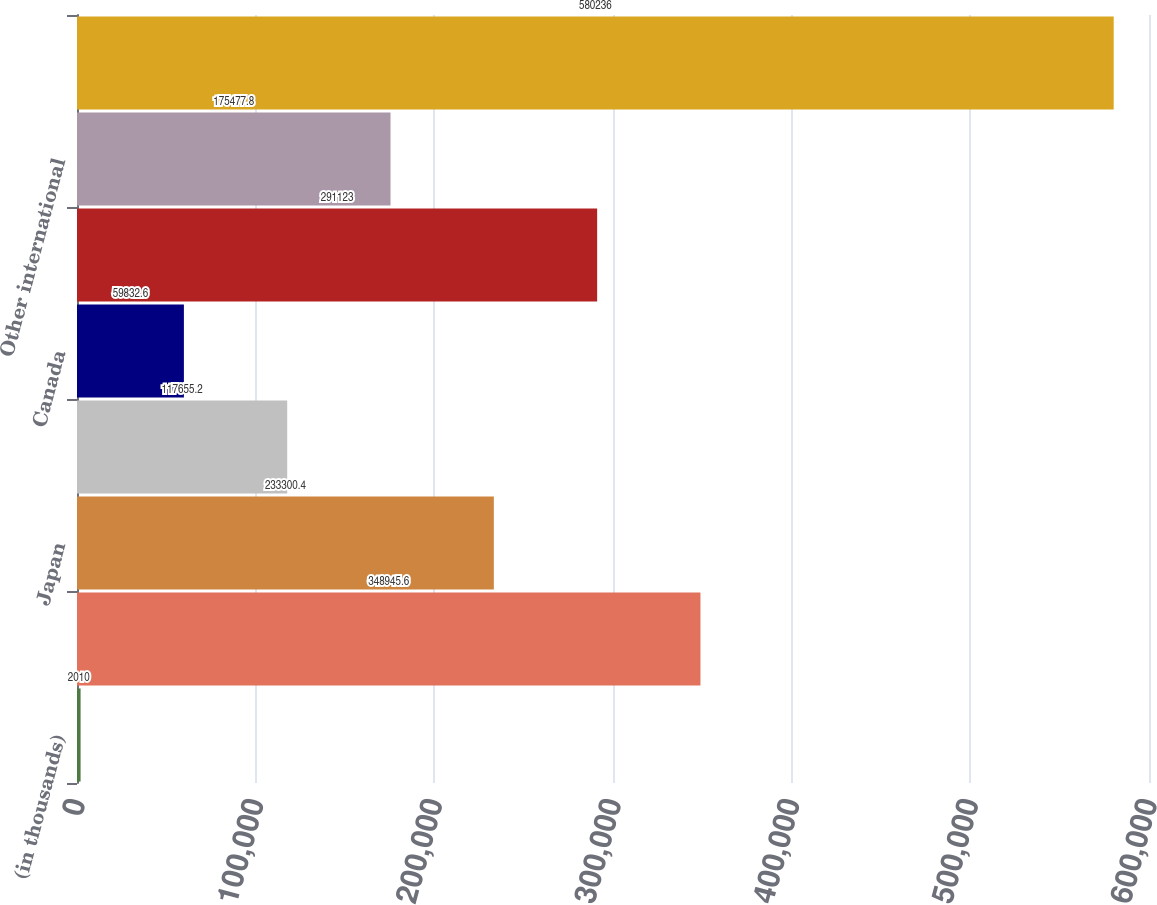<chart> <loc_0><loc_0><loc_500><loc_500><bar_chart><fcel>(in thousands)<fcel>United States<fcel>Japan<fcel>Germany<fcel>Canada<fcel>Other European<fcel>Other international<fcel>Total revenue<nl><fcel>2010<fcel>348946<fcel>233300<fcel>117655<fcel>59832.6<fcel>291123<fcel>175478<fcel>580236<nl></chart> 